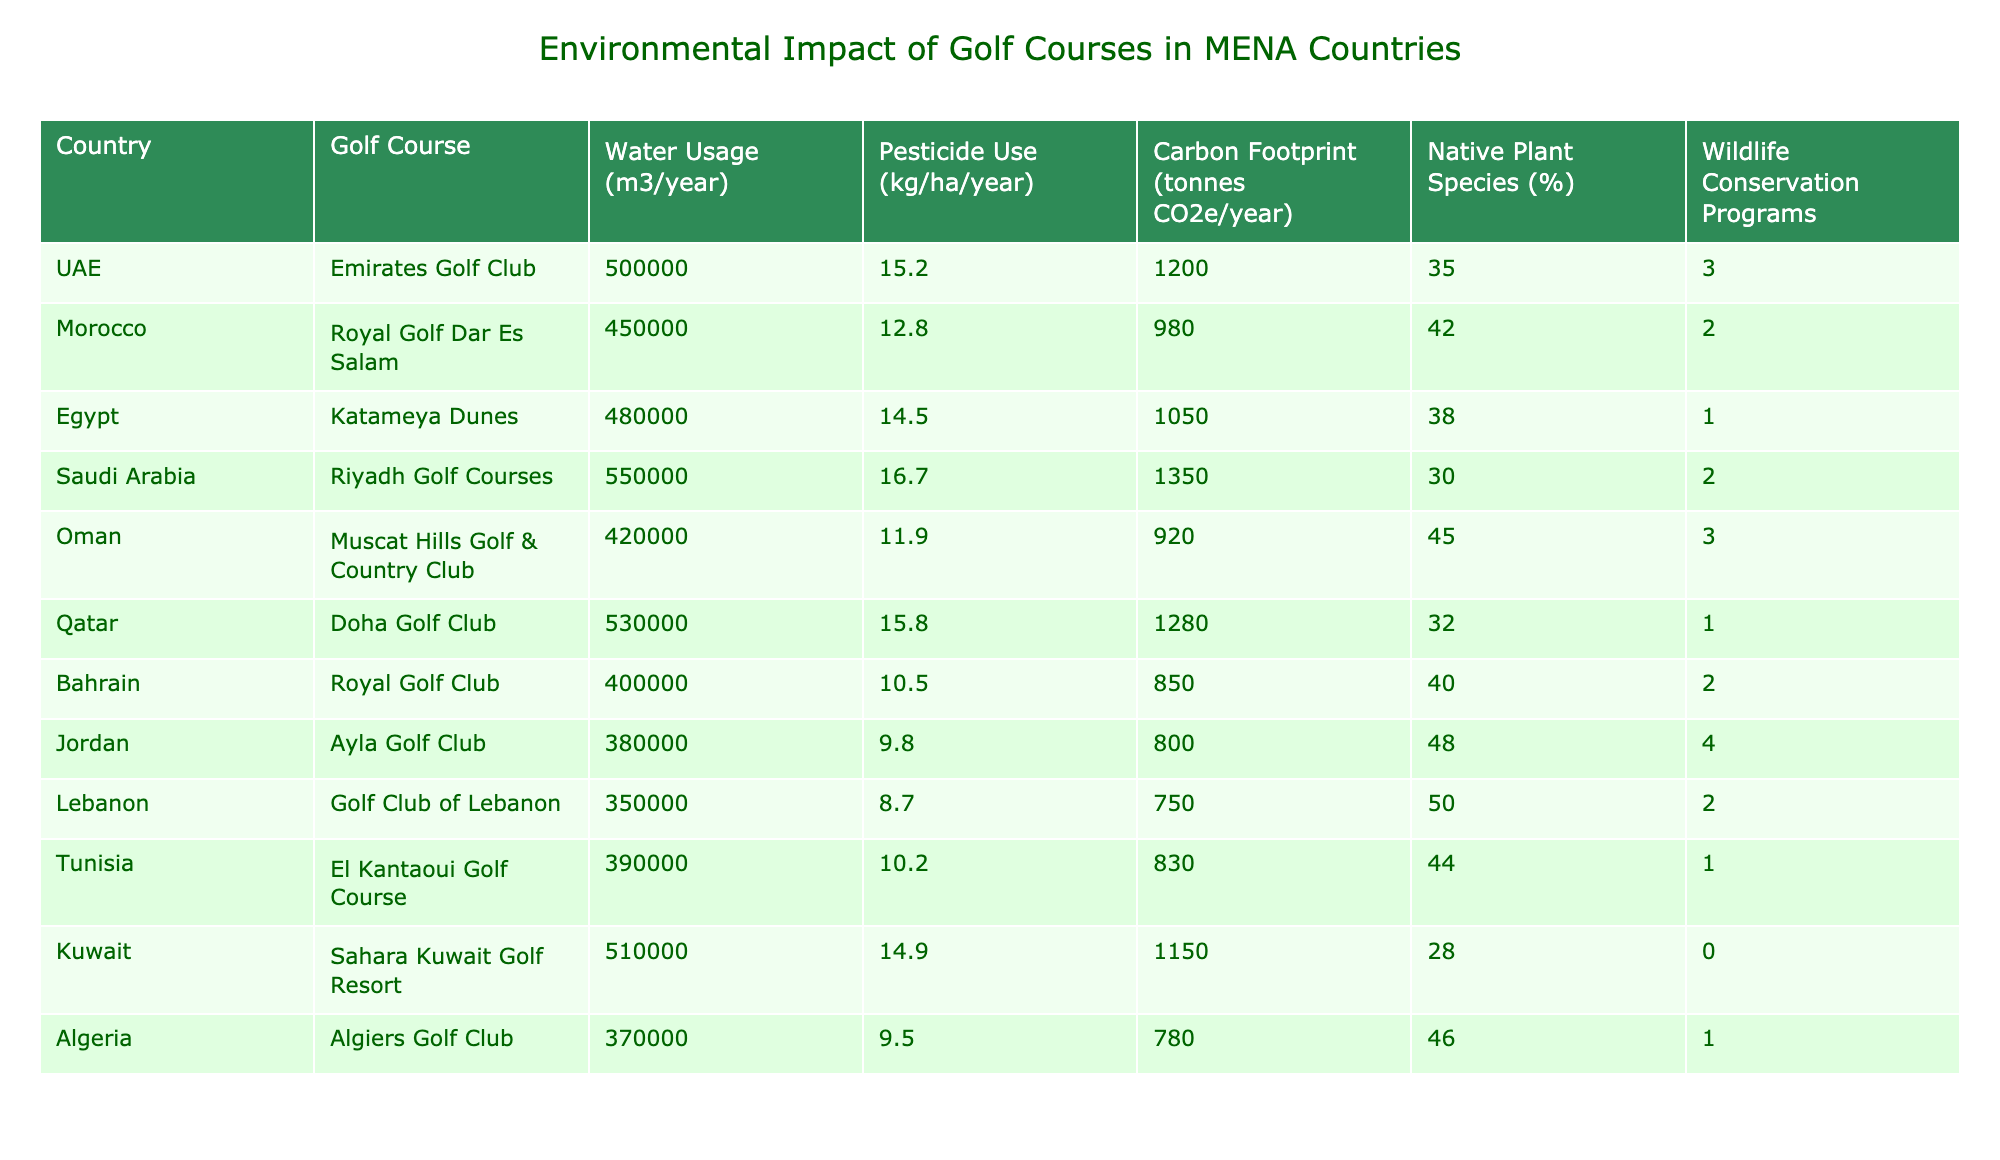What is the water usage of the Riyadh Golf Courses in Saudi Arabia? The water usage for the Riyadh Golf Courses is listed in the table specifically under the "Water Usage" column, where it shows 550,000 m3/year.
Answer: 550,000 m3/year Which golf course in the MENA region has the highest carbon footprint? By scanning the "Carbon Footprint" column for the highest value, we see that the Riyadh Golf Courses has the highest carbon footprint of 1,350 tonnes CO2e/year.
Answer: Riyadh Golf Courses How many native plant species are present in the Golf Club of Lebanon? Referring to the "Native Plant Species (%)" column, the Golf Club of Lebanon has 50%.
Answer: 50% What is the average pesticide use across all golf courses listed? To find the average, sum all pesticide uses: (15.2 + 12.8 + 14.5 + 16.7 + 11.9 + 15.8 + 10.5 + 9.8 + 8.7 + 10.2 + 14.9 + 9.5) =  151.7 kg/ha/year; there are 12 courses, so the average is 151.7 / 12 = 12.64 kg/ha/year.
Answer: 12.64 kg/ha/year Is there a golf course in MENA with a wildlife conservation program that has no native plant species? By checking the "Wildlife Conservation Programs" and "Native Plant Species (%)" columns, we note that the Sahara Kuwait Golf Resort has 0 wildlife conservation programs and 28% native plant species, so the statement is false.
Answer: No What is the total carbon footprint of all golf courses combined in MENA? To find the total, sum all carbon footprints from each course: (1200 + 980 + 1050 + 1350 + 920 + 1280 + 850 + 800 + 750 + 830 + 1150 + 780) = 10330 tonnes CO2e/year.
Answer: 10,330 tonnes CO2e/year Which country has the lowest water usage for its golf course? Looking through the "Water Usage" column, the lowest value is 350,000 m3/year, which belongs to the Golf Club of Lebanon.
Answer: Lebanon Is the percentage of native plant species higher in Oman’s Muscat Hills Golf & Country Club or in Morocco’s Royal Golf Dar Es Salam? Comparing the values: Oman has 45% native plant species and Morocco has 42%, hence Oman has a higher percentage.
Answer: Oman What is the difference in pesticide use between the UAE and Bahrain? The pesticide use for the UAE is 15.2 kg/ha/year and for Bahrain is 10.5 kg/ha/year. The difference is 15.2 - 10.5 = 4.7 kg/ha/year.
Answer: 4.7 kg/ha/year Does the Royal Golf Club in Bahrain have more pesticide use than the Golf Club of Lebanon? The Royal Golf Club uses 10.5 kg/ha/year and Golf Club of Lebanon uses 8.7 kg/ha/year, so the statement is true.
Answer: Yes What percentage of golf courses in MENA have wildlife conservation programs? There are 12 total courses, and examining the "Wildlife Conservation Programs" column reveals that 5 courses have programs; thus, the percentage is (5 / 12) * 100 = 41.67%.
Answer: 41.67% 